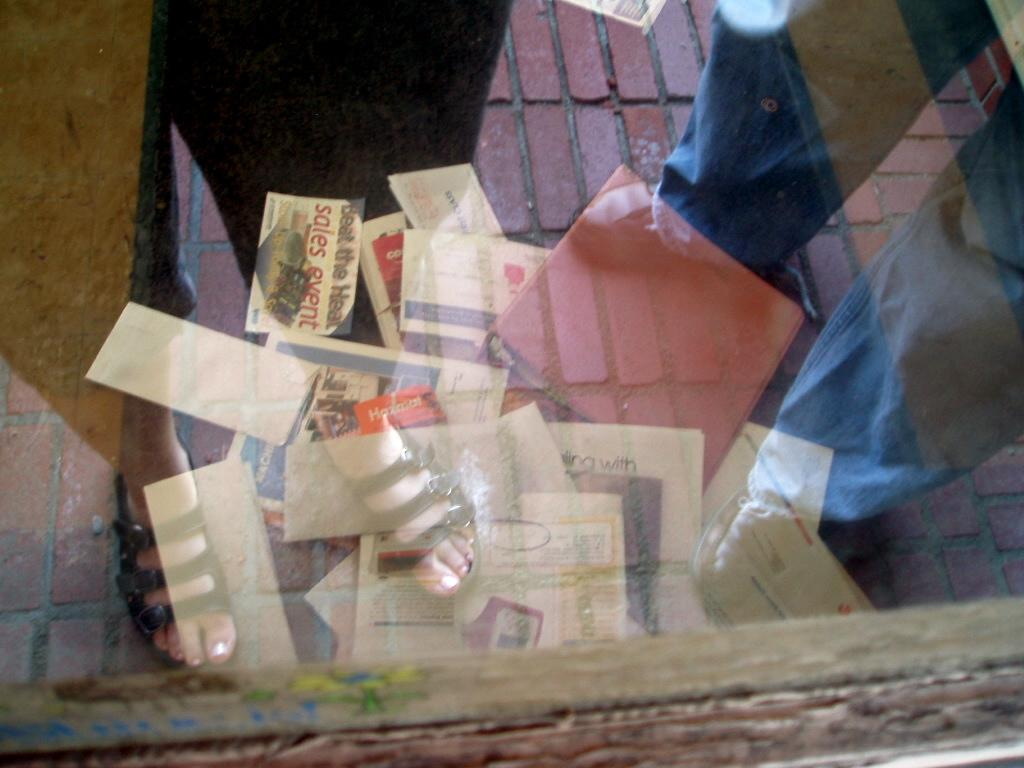What can be seen through the glass window in the image? Covers and files are placed on the floor, as seen through the window. Are there any people visible through the window? Yes, two persons are standing on the floor, as seen through the window. What type of band is playing music in the image? There is no band present in the image; it only shows a glass window with covers, files, and people on the floor. 